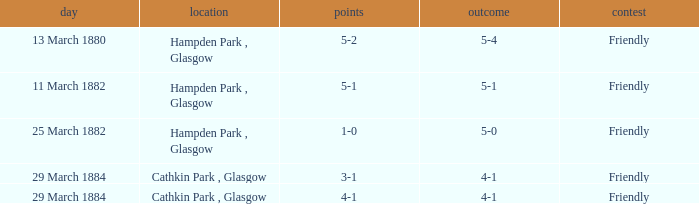Which item resulted in a score of 4-1? 3-1, 4-1. 